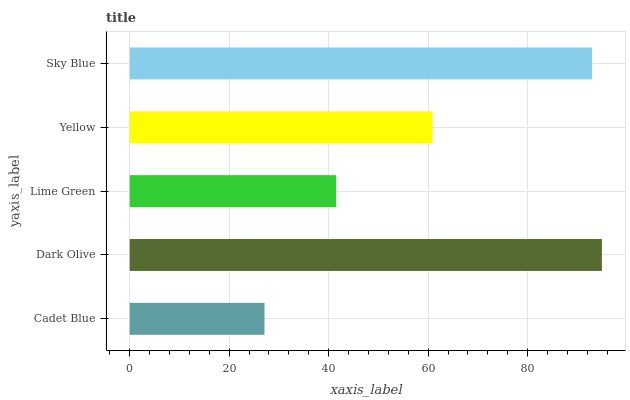Is Cadet Blue the minimum?
Answer yes or no. Yes. Is Dark Olive the maximum?
Answer yes or no. Yes. Is Lime Green the minimum?
Answer yes or no. No. Is Lime Green the maximum?
Answer yes or no. No. Is Dark Olive greater than Lime Green?
Answer yes or no. Yes. Is Lime Green less than Dark Olive?
Answer yes or no. Yes. Is Lime Green greater than Dark Olive?
Answer yes or no. No. Is Dark Olive less than Lime Green?
Answer yes or no. No. Is Yellow the high median?
Answer yes or no. Yes. Is Yellow the low median?
Answer yes or no. Yes. Is Sky Blue the high median?
Answer yes or no. No. Is Dark Olive the low median?
Answer yes or no. No. 